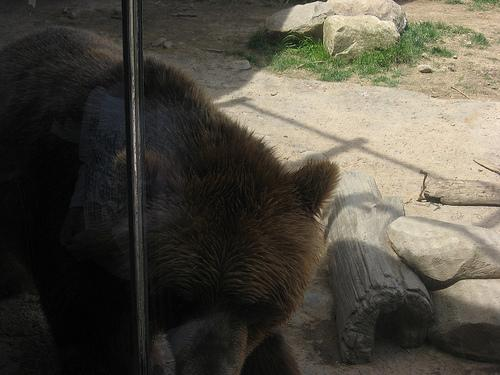Imagine you are story-telling to a child, describe the primary scenery displayed in the image. Once upon a time, in a zoo, a big brown bear with a black snout was playing in his enclosure, surrounded by green grass, logs, and rocks. Describe the scene of the image in a poetic manner. Amidst the serene green grass, the bold brown bear presides, nature's beauty in logs and rocks reside, an enclosure of tranquillity where they all reside. Express the image in the form of a haiku. Nature's art displayed. Describe the image by focusing on the colors and textures present. Within the frame, a furry brown bear with a black snout is surrounded by various shades of green grass, gray stone rocks, and a silver-colored metal pole. Describe the scene mentioning the secondary elements and their relation to the main subject. A brown bear is seen in its enclosure with logs for climbing, rocks for relaxing, and grass for traversing, as reflections of visitors appear on the glass. Write a brief summary, as a journalist, focusing on the primary subject and its environment. Today, we capture the enchanting sight of a brown bear in its enclosure at the local zoo, interacting with its habitat of logs, rocks, and lush grass. In a factual manner, mention the main object in the image and its surroundings. The image primarily features a brown bear with a black snout and brown ears, situated in an enclosure with grass, logs, rocks, and a metal pole. Write a brief description, imagining you were a tour guide in the zoo. Here we have the majestic brown bear exhibit featuring a spacious enclosure with logs, rocks, and green grass for our furry friend to explore and enjoy. Mention the principal animal featured in the photograph and its main characteristics. A brown bear with soft fur, black snout, and brown ears is in an enclosure at the zoo with logs, rocks, and grass. Describe the scene, focusing on the relation between the main subject and its environment. The brown bear in the enclosure seems to coexist harmoniously with its surroundings, such as the logs, rocks, and grass, creating a natural habitat. 